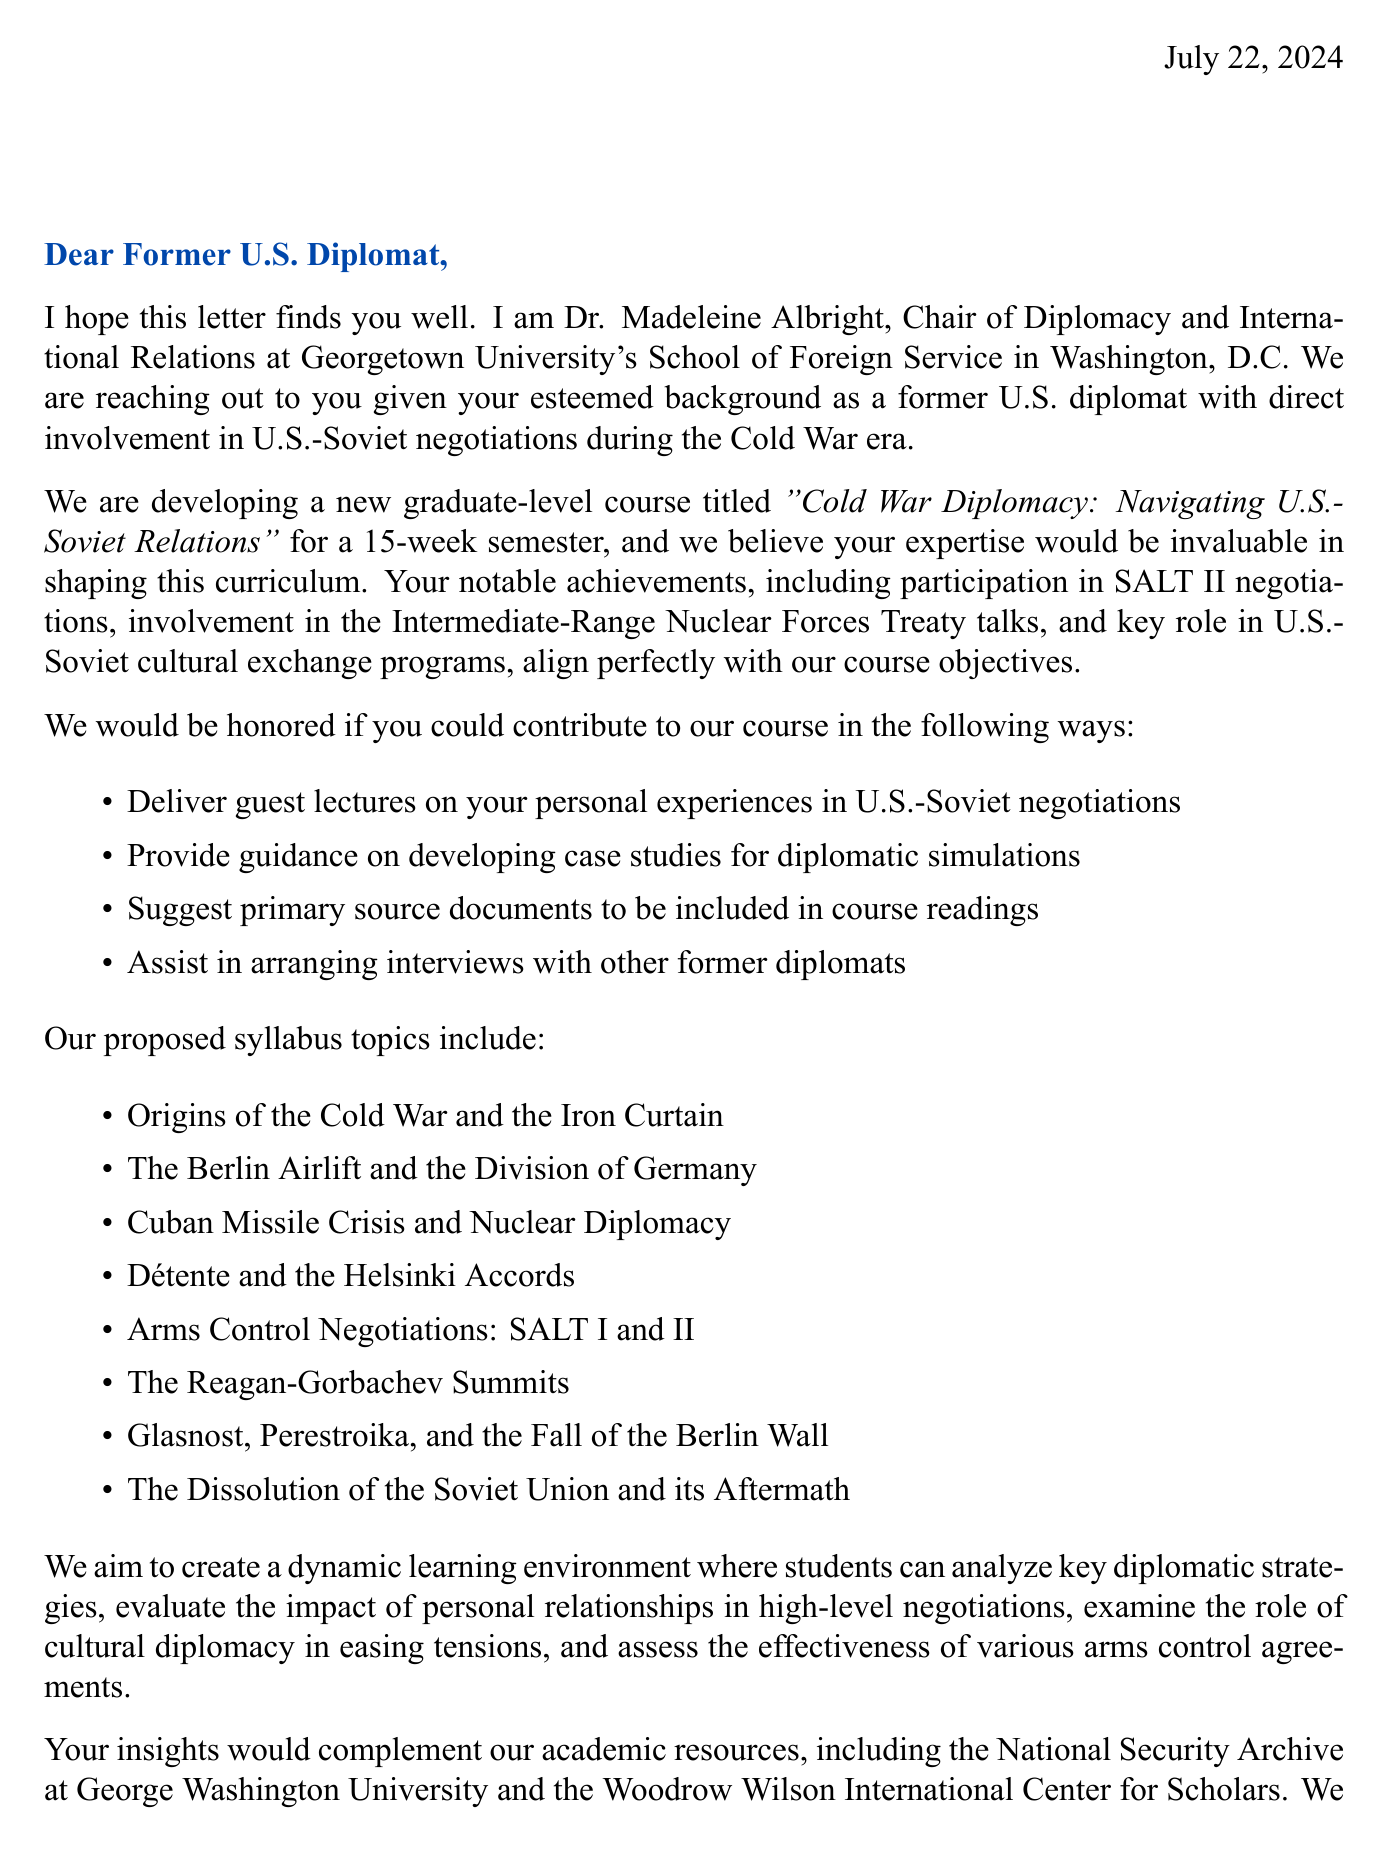What is the name of the university? The university mentioned in the document is Georgetown University.
Answer: Georgetown University Who is the contact person for this letter? The letter specifies Dr. Madeleine Albright as the contact person.
Answer: Dr. Madeleine Albright What is the proposed title for the course? The title of the course is "Cold War Diplomacy: Navigating U.S.-Soviet Relations."
Answer: Cold War Diplomacy: Navigating U.S.-Soviet Relations How many weeks will the course last? The duration of the course is stated as a 15-week semester.
Answer: 15-week semester What notable achievement is mentioned related to SALT II? The document highlights participation in SALT II negotiations as a notable achievement.
Answer: Participation in SALT II negotiations What is one of the course objectives? One of the course objectives mentioned is to analyze key diplomatic strategies employed during the Cold War.
Answer: Analyze key diplomatic strategies employed during the Cold War What type of documents are requested for course readings? The letter states that suggestions for primary source documents are requested for course readings.
Answer: Primary source documents Who are some potential guest speakers mentioned? The document lists Henry Kissinger, George Shultz, Condoleezza Rice, and Sergey Lavrov as potential guest speakers.
Answer: Henry Kissinger, George Shultz, Condoleezza Rice, Sergey Lavrov What type of deliverable involves a group activity? The course deliverable that involves a group activity is the presentation on a major U.S.-Soviet summit.
Answer: Group presentation on a major U.S.-Soviet summit 